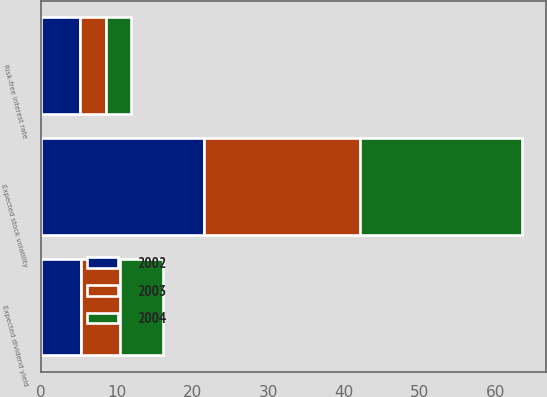<chart> <loc_0><loc_0><loc_500><loc_500><stacked_bar_chart><ecel><fcel>Risk-free interest rate<fcel>Expected stock volatility<fcel>Expected dividend yield<nl><fcel>2003<fcel>3.47<fcel>20.63<fcel>5.16<nl><fcel>2004<fcel>3.35<fcel>21.44<fcel>5.66<nl><fcel>2002<fcel>5.08<fcel>21.43<fcel>5.22<nl></chart> 